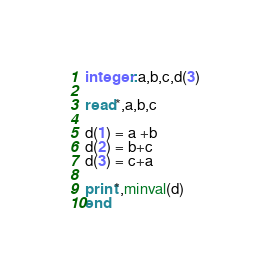<code> <loc_0><loc_0><loc_500><loc_500><_FORTRAN_>integer::a,b,c,d(3)

read*,a,b,c

d(1) = a +b
d(2) = b+c
d(3) = c+a

print*,minval(d)
end
</code> 